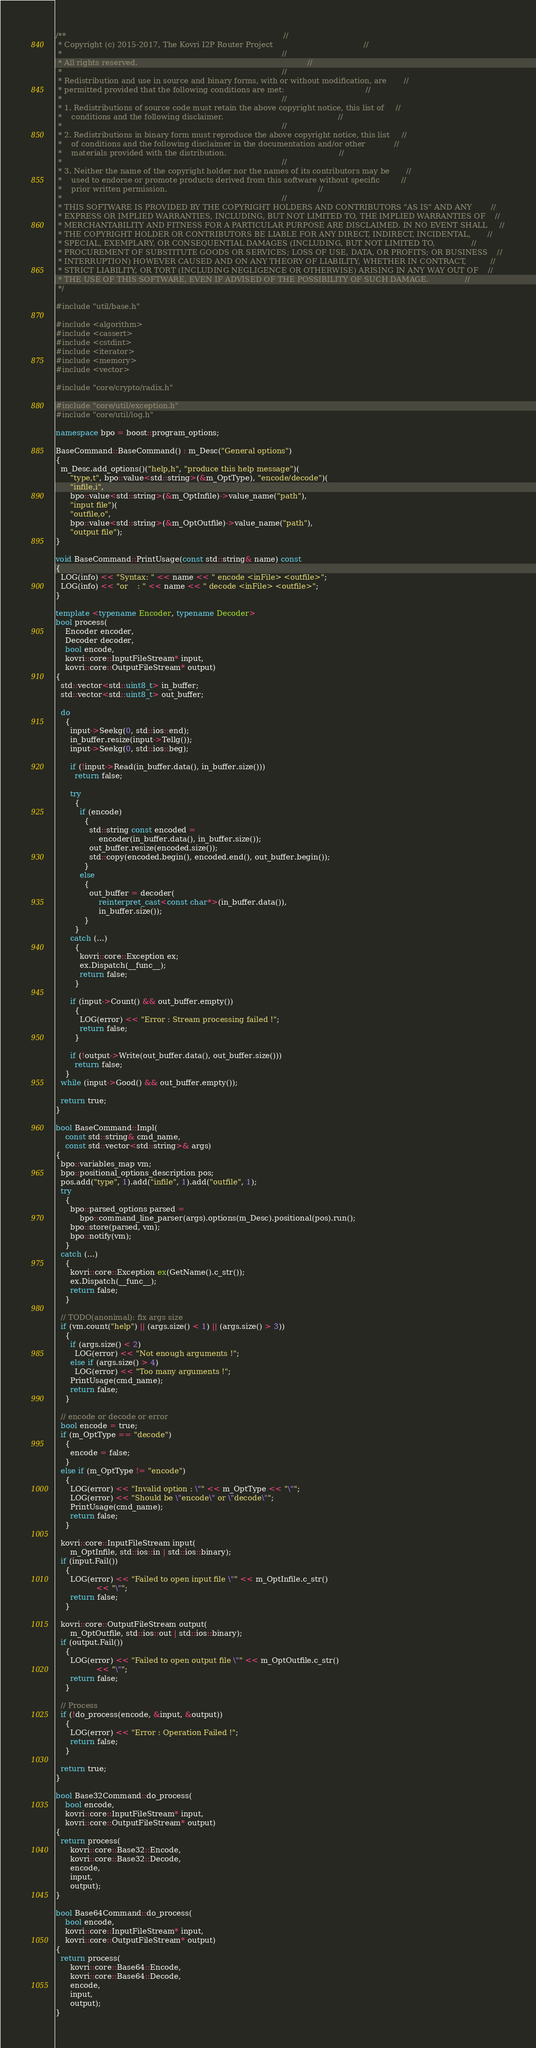<code> <loc_0><loc_0><loc_500><loc_500><_C++_>/**                                                                                           //
 * Copyright (c) 2015-2017, The Kovri I2P Router Project                                      //
 *                                                                                            //
 * All rights reserved.                                                                       //
 *                                                                                            //
 * Redistribution and use in source and binary forms, with or without modification, are       //
 * permitted provided that the following conditions are met:                                  //
 *                                                                                            //
 * 1. Redistributions of source code must retain the above copyright notice, this list of     //
 *    conditions and the following disclaimer.                                                //
 *                                                                                            //
 * 2. Redistributions in binary form must reproduce the above copyright notice, this list     //
 *    of conditions and the following disclaimer in the documentation and/or other            //
 *    materials provided with the distribution.                                               //
 *                                                                                            //
 * 3. Neither the name of the copyright holder nor the names of its contributors may be       //
 *    used to endorse or promote products derived from this software without specific         //
 *    prior written permission.                                                               //
 *                                                                                            //
 * THIS SOFTWARE IS PROVIDED BY THE COPYRIGHT HOLDERS AND CONTRIBUTORS "AS IS" AND ANY        //
 * EXPRESS OR IMPLIED WARRANTIES, INCLUDING, BUT NOT LIMITED TO, THE IMPLIED WARRANTIES OF    //
 * MERCHANTABILITY AND FITNESS FOR A PARTICULAR PURPOSE ARE DISCLAIMED. IN NO EVENT SHALL     //
 * THE COPYRIGHT HOLDER OR CONTRIBUTORS BE LIABLE FOR ANY DIRECT, INDIRECT, INCIDENTAL,       //
 * SPECIAL, EXEMPLARY, OR CONSEQUENTIAL DAMAGES (INCLUDING, BUT NOT LIMITED TO,               //
 * PROCUREMENT OF SUBSTITUTE GOODS OR SERVICES; LOSS OF USE, DATA, OR PROFITS; OR BUSINESS    //
 * INTERRUPTION) HOWEVER CAUSED AND ON ANY THEORY OF LIABILITY, WHETHER IN CONTRACT,          //
 * STRICT LIABILITY, OR TORT (INCLUDING NEGLIGENCE OR OTHERWISE) ARISING IN ANY WAY OUT OF    //
 * THE USE OF THIS SOFTWARE, EVEN IF ADVISED OF THE POSSIBILITY OF SUCH DAMAGE.               //
 */

#include "util/base.h"

#include <algorithm>
#include <cassert>
#include <cstdint>
#include <iterator>
#include <memory>
#include <vector>

#include "core/crypto/radix.h"

#include "core/util/exception.h"
#include "core/util/log.h"

namespace bpo = boost::program_options;

BaseCommand::BaseCommand() : m_Desc("General options")
{
  m_Desc.add_options()("help,h", "produce this help message")(
      "type,t", bpo::value<std::string>(&m_OptType), "encode/decode")(
      "infile,i",
      bpo::value<std::string>(&m_OptInfile)->value_name("path"),
      "input file")(
      "outfile,o",
      bpo::value<std::string>(&m_OptOutfile)->value_name("path"),
      "output file");
}

void BaseCommand::PrintUsage(const std::string& name) const
{
  LOG(info) << "Syntax: " << name << " encode <inFile> <outfile>";
  LOG(info) << "or    : " << name << " decode <inFile> <outfile>";
}

template <typename Encoder, typename Decoder>
bool process(
    Encoder encoder,
    Decoder decoder,
    bool encode,
    kovri::core::InputFileStream* input,
    kovri::core::OutputFileStream* output)
{
  std::vector<std::uint8_t> in_buffer;
  std::vector<std::uint8_t> out_buffer;

  do
    {
      input->Seekg(0, std::ios::end);
      in_buffer.resize(input->Tellg());
      input->Seekg(0, std::ios::beg);

      if (!input->Read(in_buffer.data(), in_buffer.size()))
        return false;

      try
        {
          if (encode)
            {
              std::string const encoded =
                  encoder(in_buffer.data(), in_buffer.size());
              out_buffer.resize(encoded.size());
              std::copy(encoded.begin(), encoded.end(), out_buffer.begin());
            }
          else
            {
              out_buffer = decoder(
                  reinterpret_cast<const char*>(in_buffer.data()),
                  in_buffer.size());
            }
        }
      catch (...)
        {
          kovri::core::Exception ex;
          ex.Dispatch(__func__);
          return false;
        }

      if (input->Count() && out_buffer.empty())
        {
          LOG(error) << "Error : Stream processing failed !";
          return false;
        }

      if (!output->Write(out_buffer.data(), out_buffer.size()))
        return false;
    }
  while (input->Good() && out_buffer.empty());

  return true;
}

bool BaseCommand::Impl(
    const std::string& cmd_name,
    const std::vector<std::string>& args)
{
  bpo::variables_map vm;
  bpo::positional_options_description pos;
  pos.add("type", 1).add("infile", 1).add("outfile", 1);
  try
    {
      bpo::parsed_options parsed =
          bpo::command_line_parser(args).options(m_Desc).positional(pos).run();
      bpo::store(parsed, vm);
      bpo::notify(vm);
    }
  catch (...)
    {
      kovri::core::Exception ex(GetName().c_str());
      ex.Dispatch(__func__);
      return false;
    }

  // TODO(anonimal): fix args size
  if (vm.count("help") || (args.size() < 1) || (args.size() > 3))
    {
      if (args.size() < 2)
        LOG(error) << "Not enough arguments !";
      else if (args.size() > 4)
        LOG(error) << "Too many arguments !";
      PrintUsage(cmd_name);
      return false;
    }

  // encode or decode or error
  bool encode = true;
  if (m_OptType == "decode")
    {
      encode = false;
    }
  else if (m_OptType != "encode")
    {
      LOG(error) << "Invalid option : \"" << m_OptType << "\"";
      LOG(error) << "Should be \"encode\" or \"decode\"";
      PrintUsage(cmd_name);
      return false;
    }

  kovri::core::InputFileStream input(
      m_OptInfile, std::ios::in | std::ios::binary);
  if (input.Fail())
    {
      LOG(error) << "Failed to open input file \"" << m_OptInfile.c_str()
                 << "\"";
      return false;
    }

  kovri::core::OutputFileStream output(
      m_OptOutfile, std::ios::out | std::ios::binary);
  if (output.Fail())
    {
      LOG(error) << "Failed to open output file \"" << m_OptOutfile.c_str()
                 << "\"";
      return false;
    }

  // Process
  if (!do_process(encode, &input, &output))
    {
      LOG(error) << "Error : Operation Failed !";
      return false;
    }

  return true;
}

bool Base32Command::do_process(
    bool encode,
    kovri::core::InputFileStream* input,
    kovri::core::OutputFileStream* output)
{
  return process(
      kovri::core::Base32::Encode,
      kovri::core::Base32::Decode,
      encode,
      input,
      output);
}

bool Base64Command::do_process(
    bool encode,
    kovri::core::InputFileStream* input,
    kovri::core::OutputFileStream* output)
{
  return process(
      kovri::core::Base64::Encode,
      kovri::core::Base64::Decode,
      encode,
      input,
      output);
}
</code> 